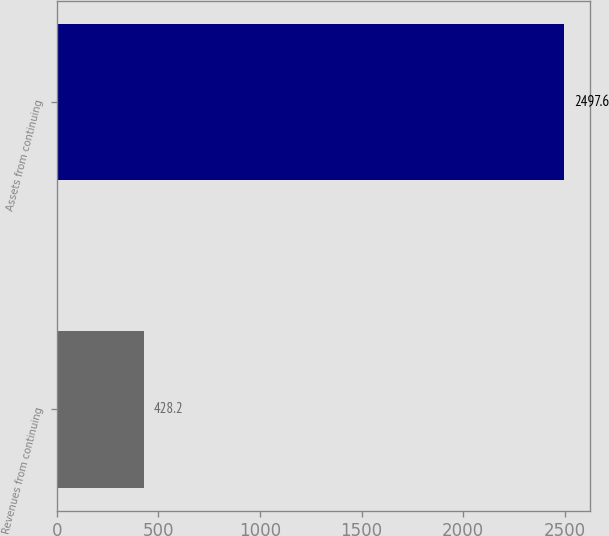Convert chart. <chart><loc_0><loc_0><loc_500><loc_500><bar_chart><fcel>Revenues from continuing<fcel>Assets from continuing<nl><fcel>428.2<fcel>2497.6<nl></chart> 